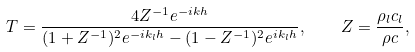Convert formula to latex. <formula><loc_0><loc_0><loc_500><loc_500>T = \frac { 4 Z ^ { - 1 } e ^ { - i k h } } { ( 1 + Z ^ { - 1 } ) ^ { 2 } e ^ { - i k _ { l } h } - ( 1 - Z ^ { - 1 } ) ^ { 2 } e ^ { i k _ { l } h } } , \quad Z = \frac { \rho _ { l } c _ { l } } { \rho c } ,</formula> 